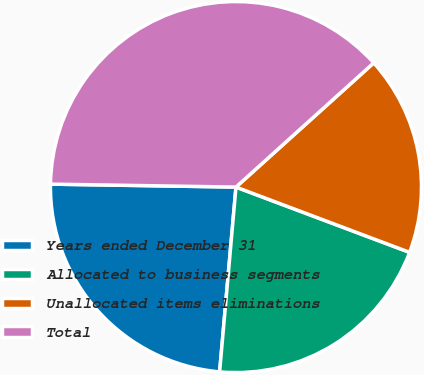<chart> <loc_0><loc_0><loc_500><loc_500><pie_chart><fcel>Years ended December 31<fcel>Allocated to business segments<fcel>Unallocated items eliminations<fcel>Total<nl><fcel>23.85%<fcel>20.68%<fcel>17.4%<fcel>38.07%<nl></chart> 